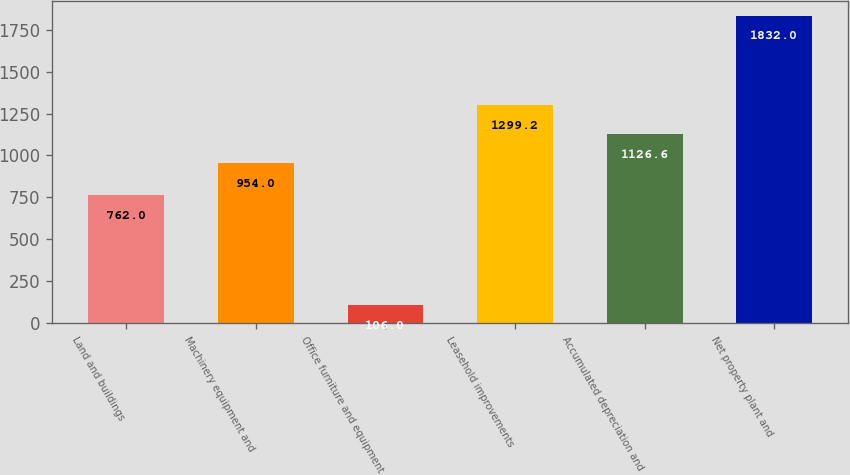Convert chart. <chart><loc_0><loc_0><loc_500><loc_500><bar_chart><fcel>Land and buildings<fcel>Machinery equipment and<fcel>Office furniture and equipment<fcel>Leasehold improvements<fcel>Accumulated depreciation and<fcel>Net property plant and<nl><fcel>762<fcel>954<fcel>106<fcel>1299.2<fcel>1126.6<fcel>1832<nl></chart> 